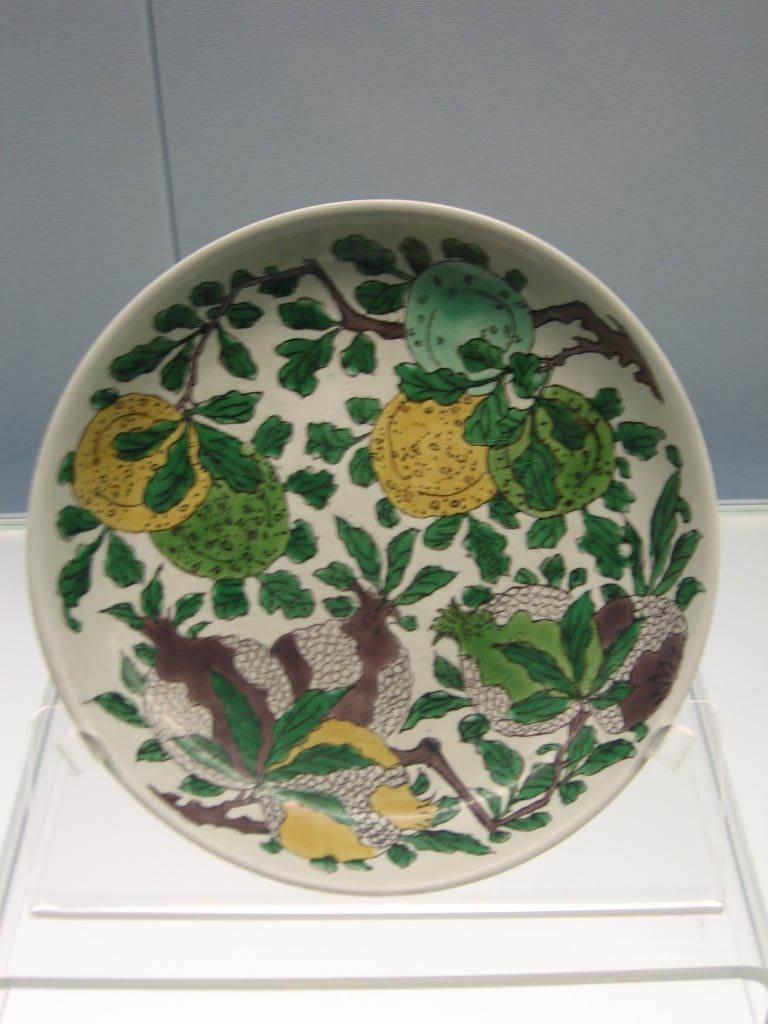Describe this image in one or two sentences. In this picture we can see a plate on the surface with design on it and in the background we can see the wall. 